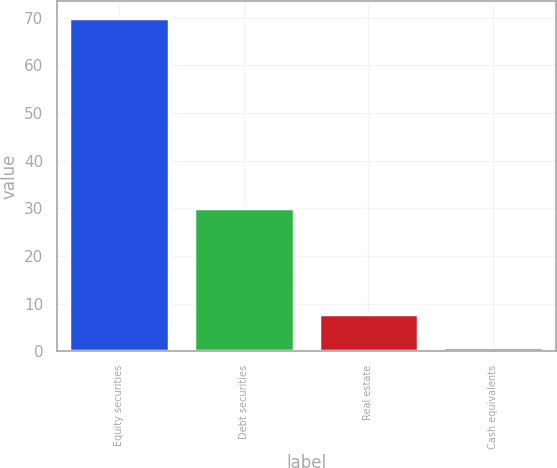Convert chart to OTSL. <chart><loc_0><loc_0><loc_500><loc_500><bar_chart><fcel>Equity securities<fcel>Debt securities<fcel>Real estate<fcel>Cash equivalents<nl><fcel>70<fcel>30<fcel>7.87<fcel>0.97<nl></chart> 